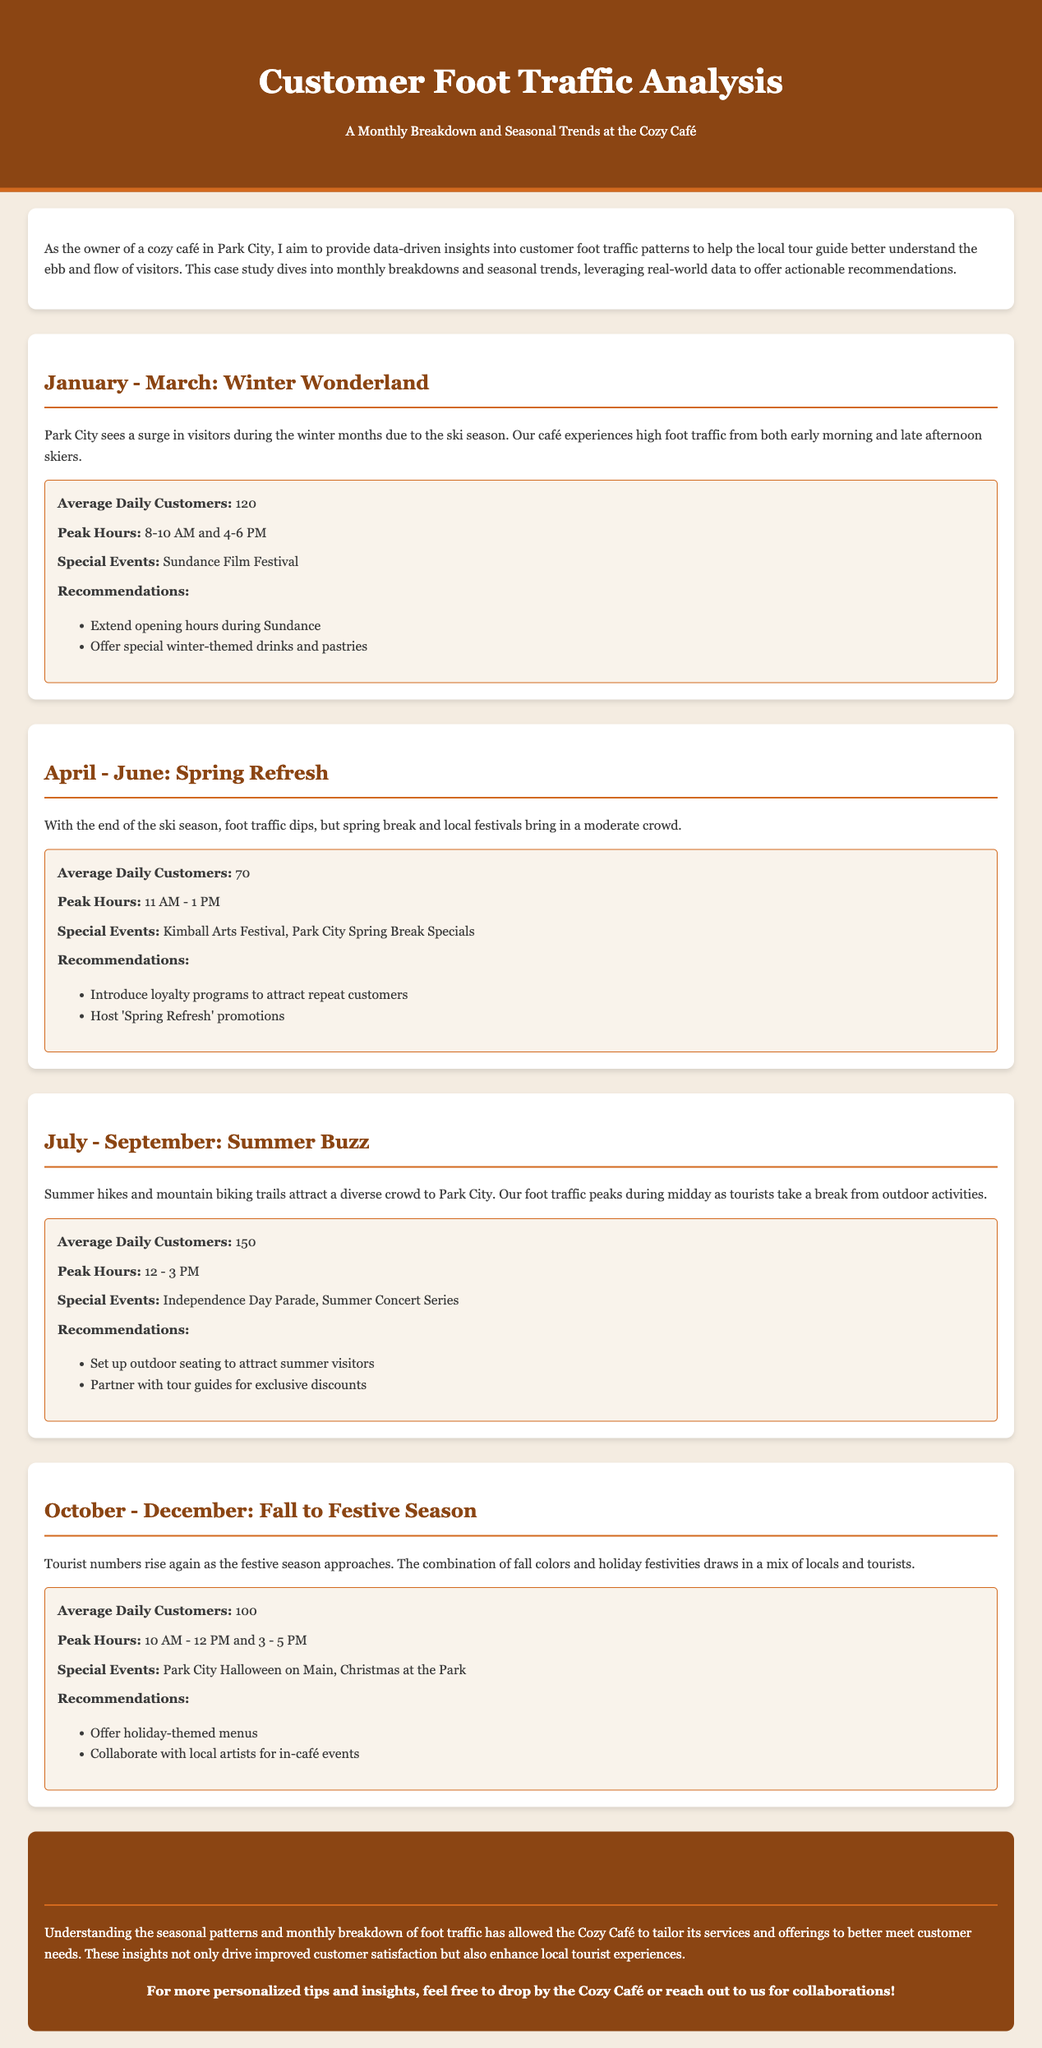what is the average daily number of customers in January to March? The average daily number of customers in this period is specifically stated in the document as 120.
Answer: 120 what are the peak hours for foot traffic in July to September? The document outlines the peak hours for this summer period, which are from 12 PM to 3 PM.
Answer: 12 - 3 PM what special event is mentioned for the fall months? The document includes “Park City Halloween on Main” as a special event occurring during the fall months.
Answer: Park City Halloween on Main how many average daily customers are there in April to June? This figure is noted in the document, specifically indicated as 70.
Answer: 70 what recommendation is made for the winter months? A recommendation for the winter months includes “Offer special winter-themed drinks and pastries.”
Answer: Offer special winter-themed drinks and pastries which season has the highest average daily customer count? The document specifies that July to September, which represents summer, has the highest average daily customer count.
Answer: July - September what are the peak hours for foot traffic in January to March? The document mentions the peak hours during this period are 8-10 AM and 4-6 PM.
Answer: 8-10 AM and 4-6 PM what is one of the recommendations for the summer months? The document lists “Set up outdoor seating to attract summer visitors” as a recommendation for the summer months.
Answer: Set up outdoor seating to attract summer visitors 